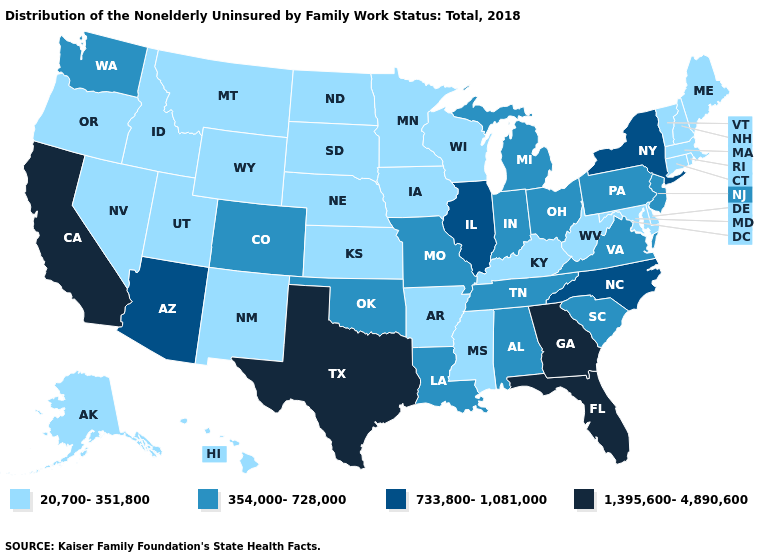What is the value of Michigan?
Keep it brief. 354,000-728,000. What is the lowest value in the USA?
Concise answer only. 20,700-351,800. Does Georgia have the lowest value in the USA?
Short answer required. No. Among the states that border Massachusetts , which have the highest value?
Answer briefly. New York. What is the value of Maine?
Keep it brief. 20,700-351,800. Does the map have missing data?
Answer briefly. No. What is the highest value in the MidWest ?
Keep it brief. 733,800-1,081,000. What is the lowest value in states that border Oregon?
Keep it brief. 20,700-351,800. How many symbols are there in the legend?
Keep it brief. 4. Name the states that have a value in the range 354,000-728,000?
Quick response, please. Alabama, Colorado, Indiana, Louisiana, Michigan, Missouri, New Jersey, Ohio, Oklahoma, Pennsylvania, South Carolina, Tennessee, Virginia, Washington. Name the states that have a value in the range 733,800-1,081,000?
Write a very short answer. Arizona, Illinois, New York, North Carolina. What is the value of Montana?
Answer briefly. 20,700-351,800. What is the value of Maine?
Give a very brief answer. 20,700-351,800. Name the states that have a value in the range 1,395,600-4,890,600?
Keep it brief. California, Florida, Georgia, Texas. 